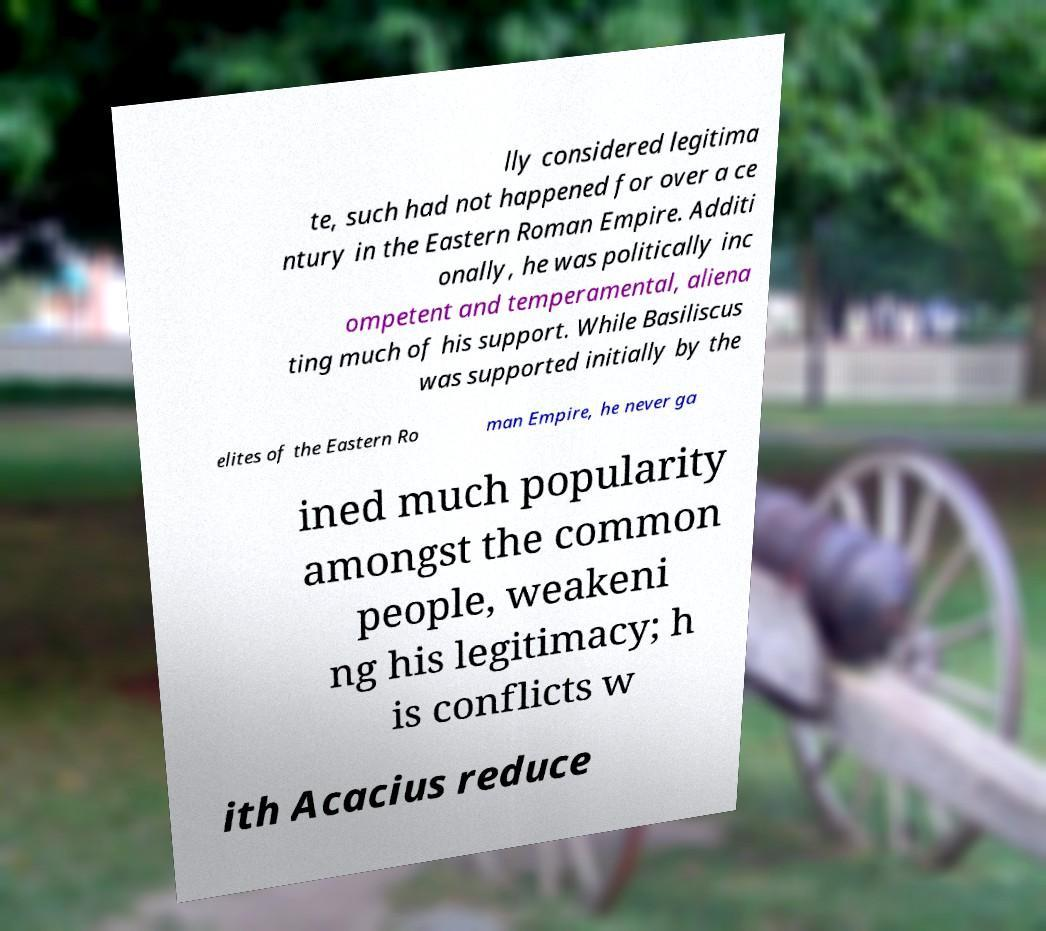There's text embedded in this image that I need extracted. Can you transcribe it verbatim? lly considered legitima te, such had not happened for over a ce ntury in the Eastern Roman Empire. Additi onally, he was politically inc ompetent and temperamental, aliena ting much of his support. While Basiliscus was supported initially by the elites of the Eastern Ro man Empire, he never ga ined much popularity amongst the common people, weakeni ng his legitimacy; h is conflicts w ith Acacius reduce 